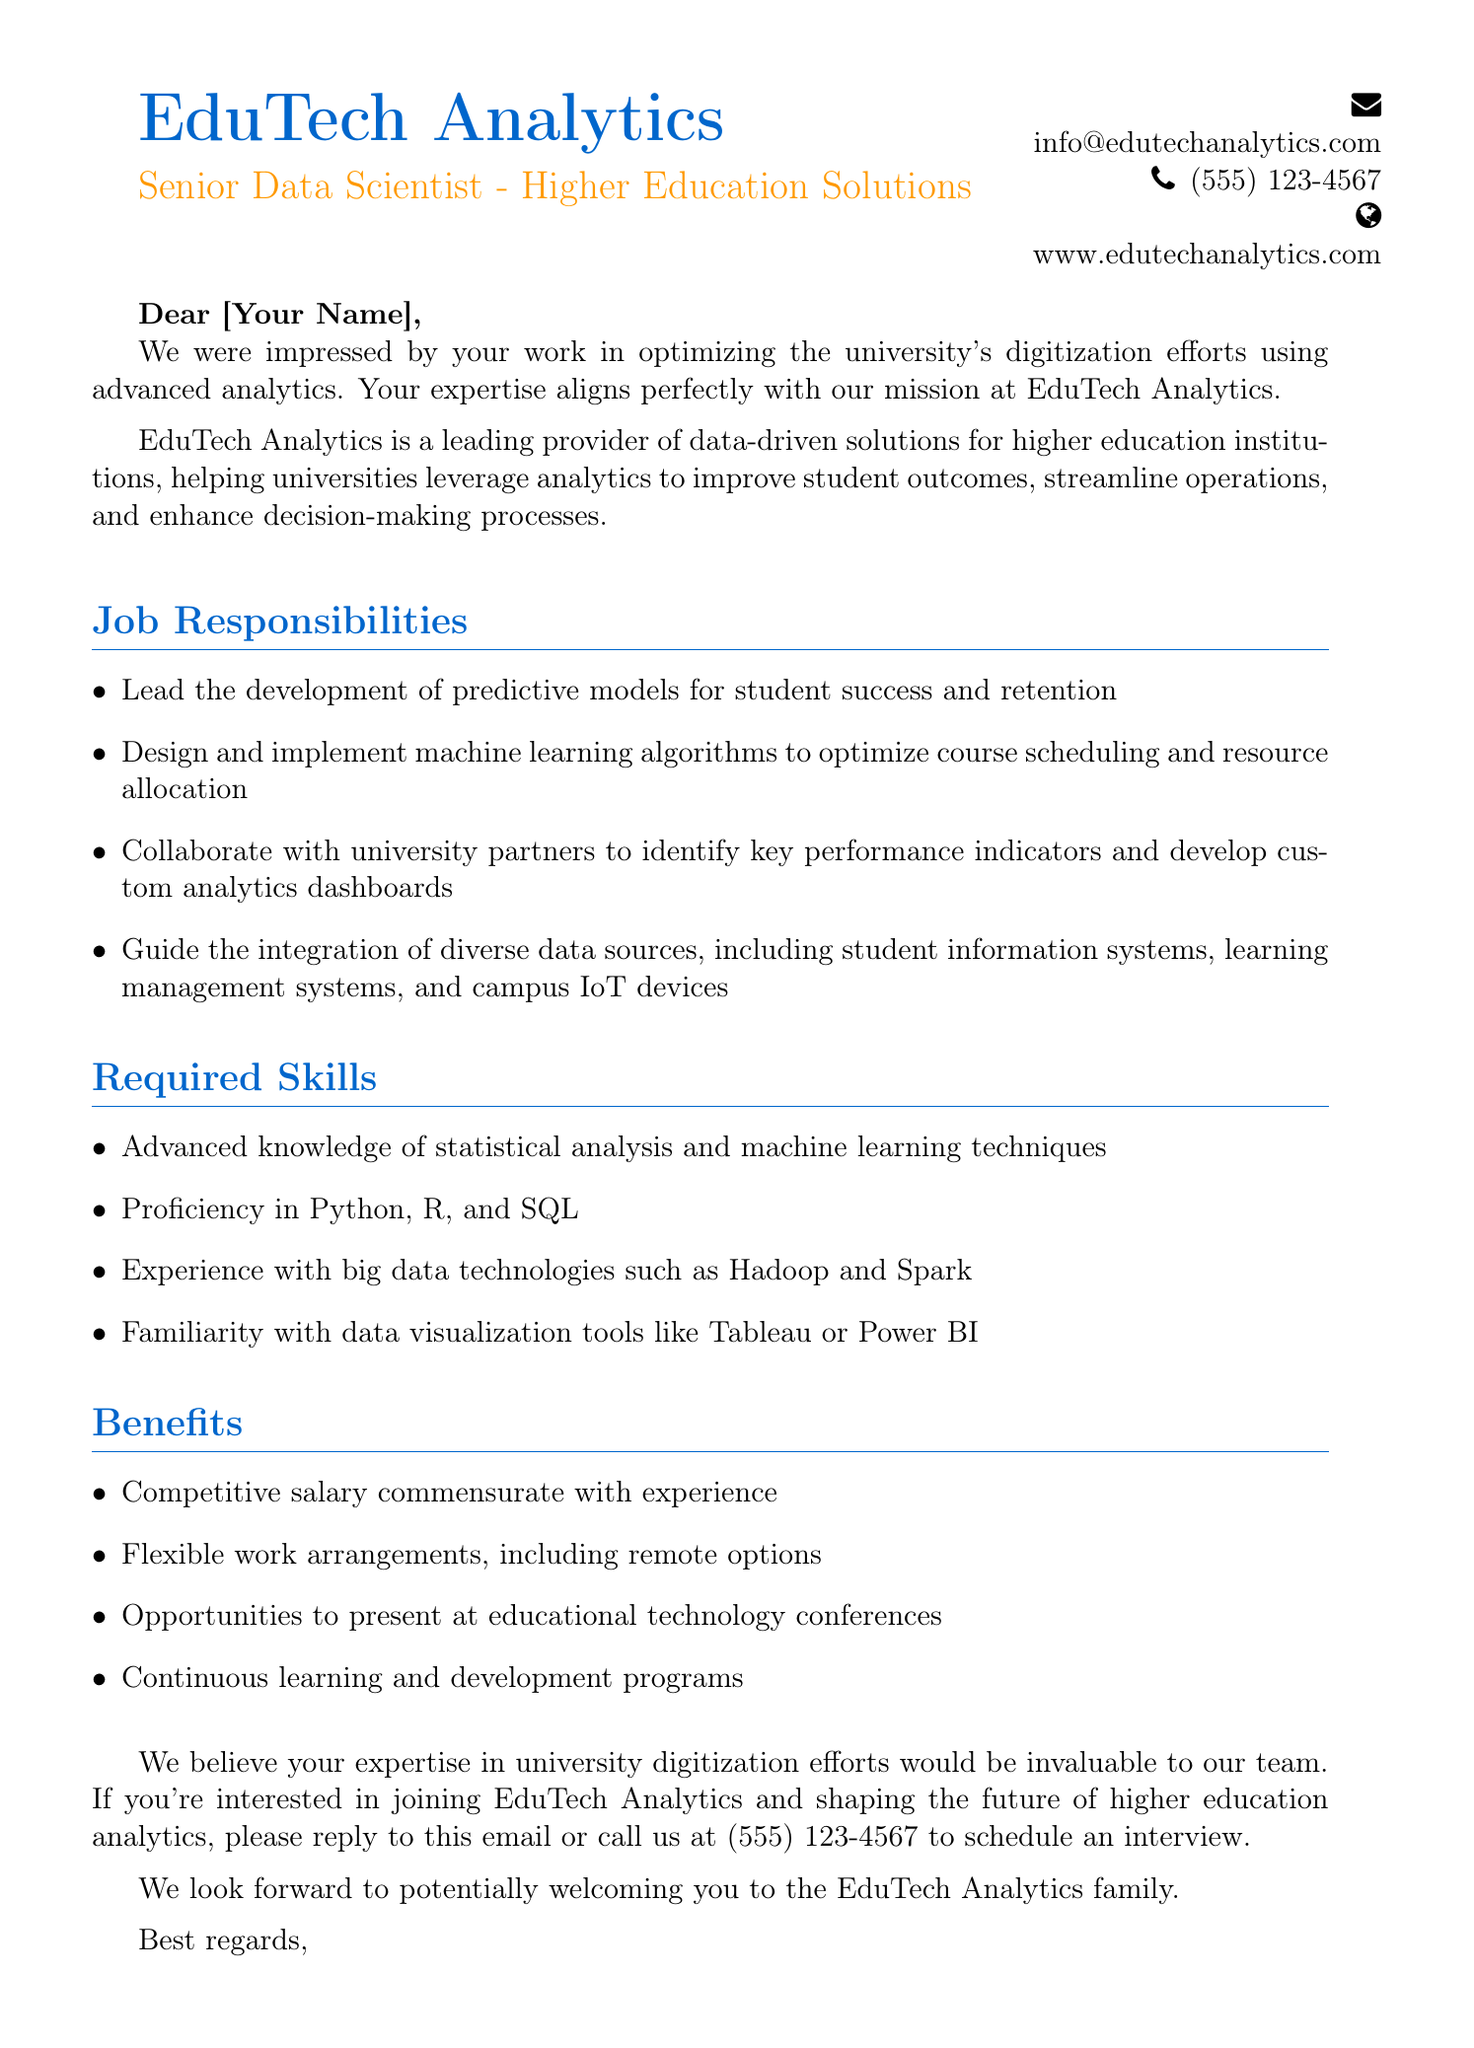What is the company name? The company name is mentioned at the top of the document as the sender's identity.
Answer: EduTech Analytics What is the job title offered? The job title is specified clearly in a highlighted format following the company name.
Answer: Senior Data Scientist - Higher Education Solutions Who is the Talent Acquisition Manager? The document provides the name of the person responsible for recruitment.
Answer: Sarah Thompson What is one of the job responsibilities? The document lists several responsibilities under a specific section.
Answer: Lead the development of predictive models for student success and retention What is a required skill? The skills necessary for the position are outlined in a distinct section.
Answer: Proficiency in Python, R, and SQL What type of benefits are offered? The benefits are listed, showing what the company provides to employees.
Answer: Competitive salary commensurate with experience How can one apply for the position? The document provides a call to action detailing how to express interest.
Answer: Reply to this email or call us at (555) 123-4567 What is the main focus of EduTech Analytics? The document describes the purpose and focus of the company.
Answer: Improving student outcomes What can potential employees expect regarding work arrangements? The document outlines the flexibility offered in terms of working conditions.
Answer: Flexible work arrangements, including remote options What is the tone of the closing statement? The closing paragraph reflects the sentiments conveyed by the sender.
Answer: Welcoming 